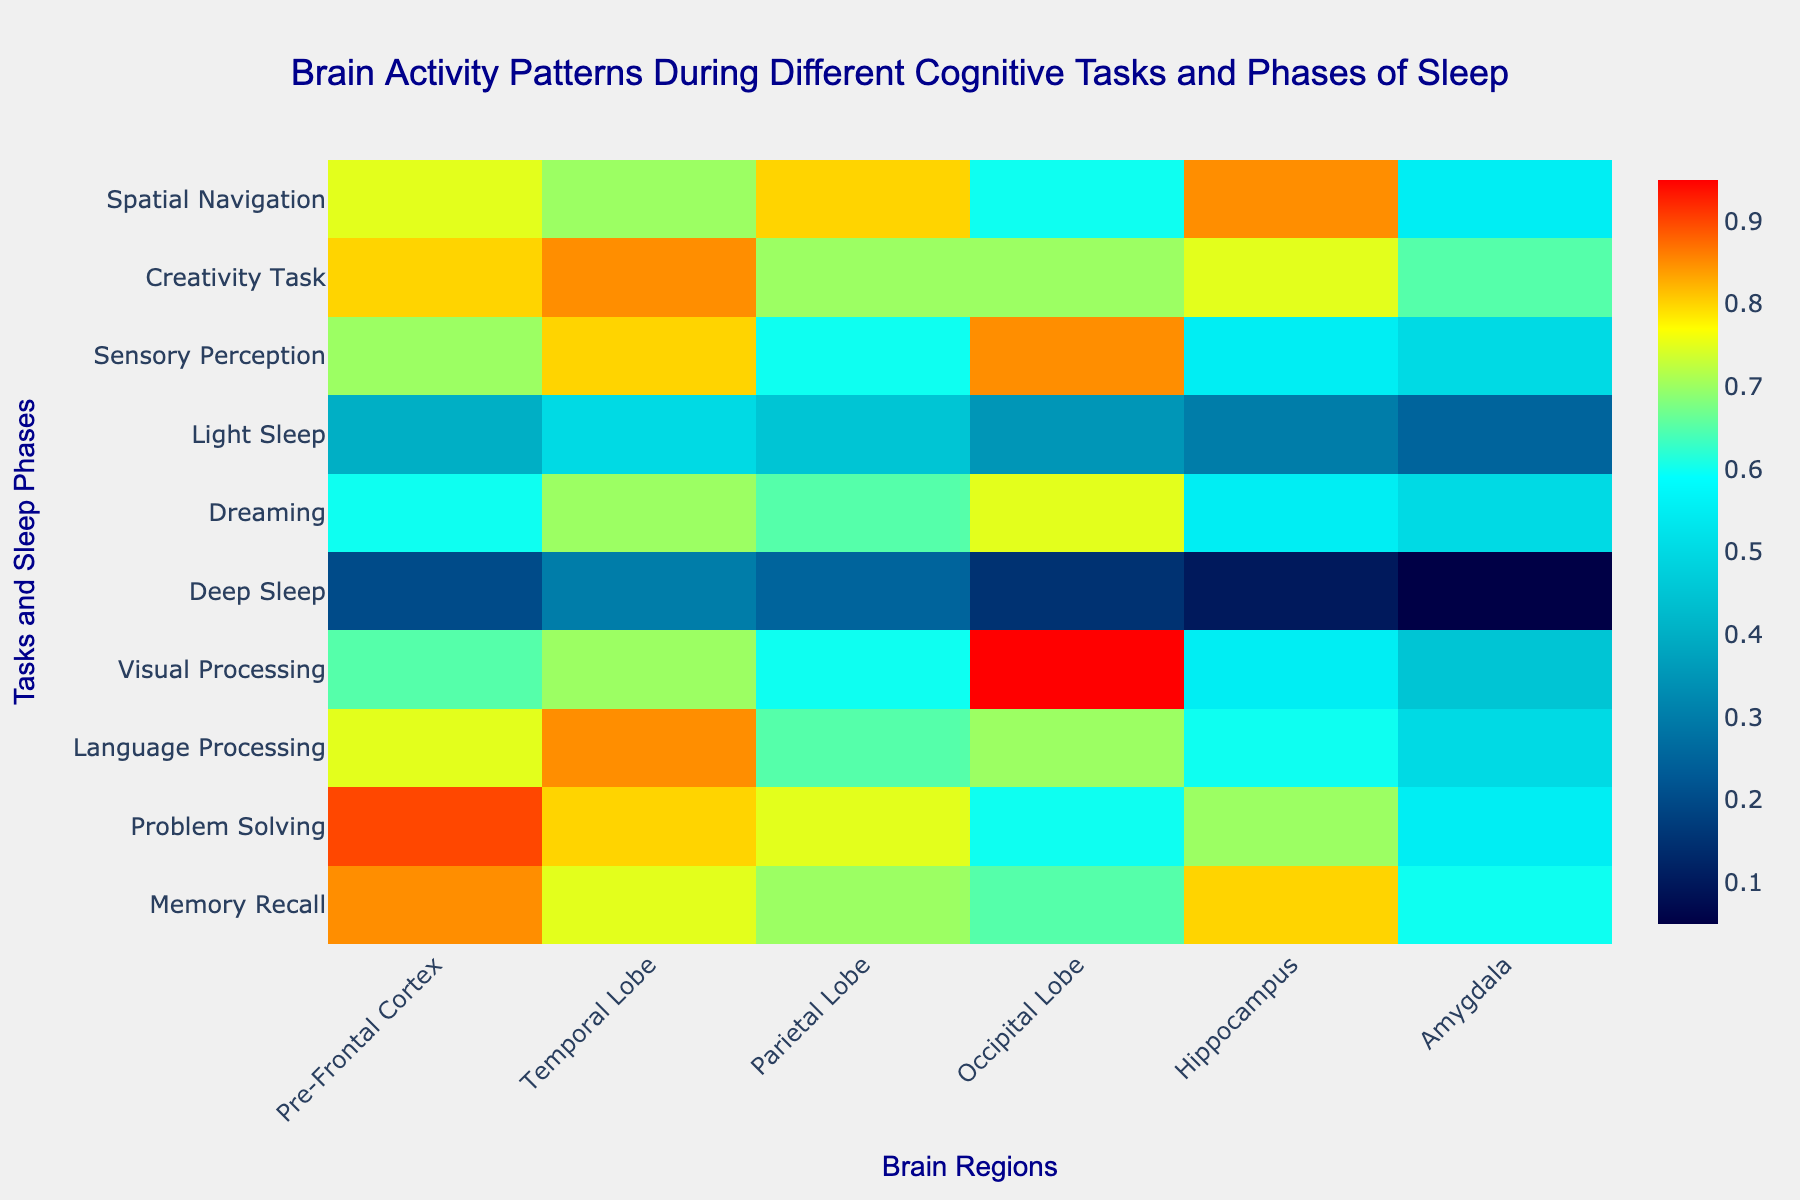What is the title of the heatmap? The title is located at the top of the heatmap, describing what is being visualized. You can identify it by its font size and colour, which stand out.
Answer: Brain Activity Patterns During Different Cognitive Tasks and Phases of Sleep Which brain region shows the highest activity level during Problem Solving while awake? To find the highest activity level during Problem Solving, look at the row labeled "Problem Solving" under the "Awake" phase, then find the highest value across the brain regions.
Answer: Pre-Frontal Cortex What is the lowest activity level in any brain region during Deep Sleep in the NREM phase? Locate the "Deep Sleep" row under the "NREM" phase and identify the minimum value in that row. This corresponds to the lowest activity in any brain region during Deep Sleep.
Answer: 0.05 Compare the activity levels of the Occipital Lobe during Visual Processing and during Sensory Perception while awake. Which is higher? Look at the rows for "Visual Processing" and "Sensory Perception" under the "Awake" phase. Compare the values in the Occipital Lobe column for both tasks.
Answer: Visual Processing What is the average activity level in the Hippocampus during Awake phase cognitive tasks? Sum the activity levels in the "Hippocampus" column for all tasks listed under the "Awake" phase, then divide by the number of tasks. The tasks include Memory Recall, Problem Solving, Language Processing, Visual Processing, Sensory Perception, Creativity Task, and Spatial Navigation.
Answer: (0.80 + 0.70 + 0.60 + 0.55 + 0.55 + 0.75 + 0.85) / 7 = 0.68 During Light Sleep in the NREM phase, which brain region shows the highest activity level? Locate the "Light Sleep" row under the "NREM" phase and identify the highest value within that row to determine the most active brain region during Light Sleep.
Answer: Temporal Lobe Which cognitive task shows the highest activity in the Amygdala during the Awake phase? Check the activity levels in the Amygdala column for all tasks listed under the "Awake" phase and identify the task with the highest value.
Answer: Creativity Task Is the activity in the Parietal Lobe higher during Deep Sleep or Light Sleep in the NREM phase? Compare the values in the "Parietal Lobe" column for "Deep Sleep" and "Light Sleep" under the "NREM" phase to answer which has a higher activity level.
Answer: Light Sleep What is the sum of activity levels in the Temporal Lobe for all tasks and sleep phases? Add the values in the "Temporal Lobe" column for all tasks and sleep phases. This involves summing the data points related to each task/phase from the heatmap.
Answer: 0.75 + 0.80 + 0.85 + 0.70 + 0.30 + 0.70 + 0.50 + 0.80 + 0.85 + 0.70 = 6.95 